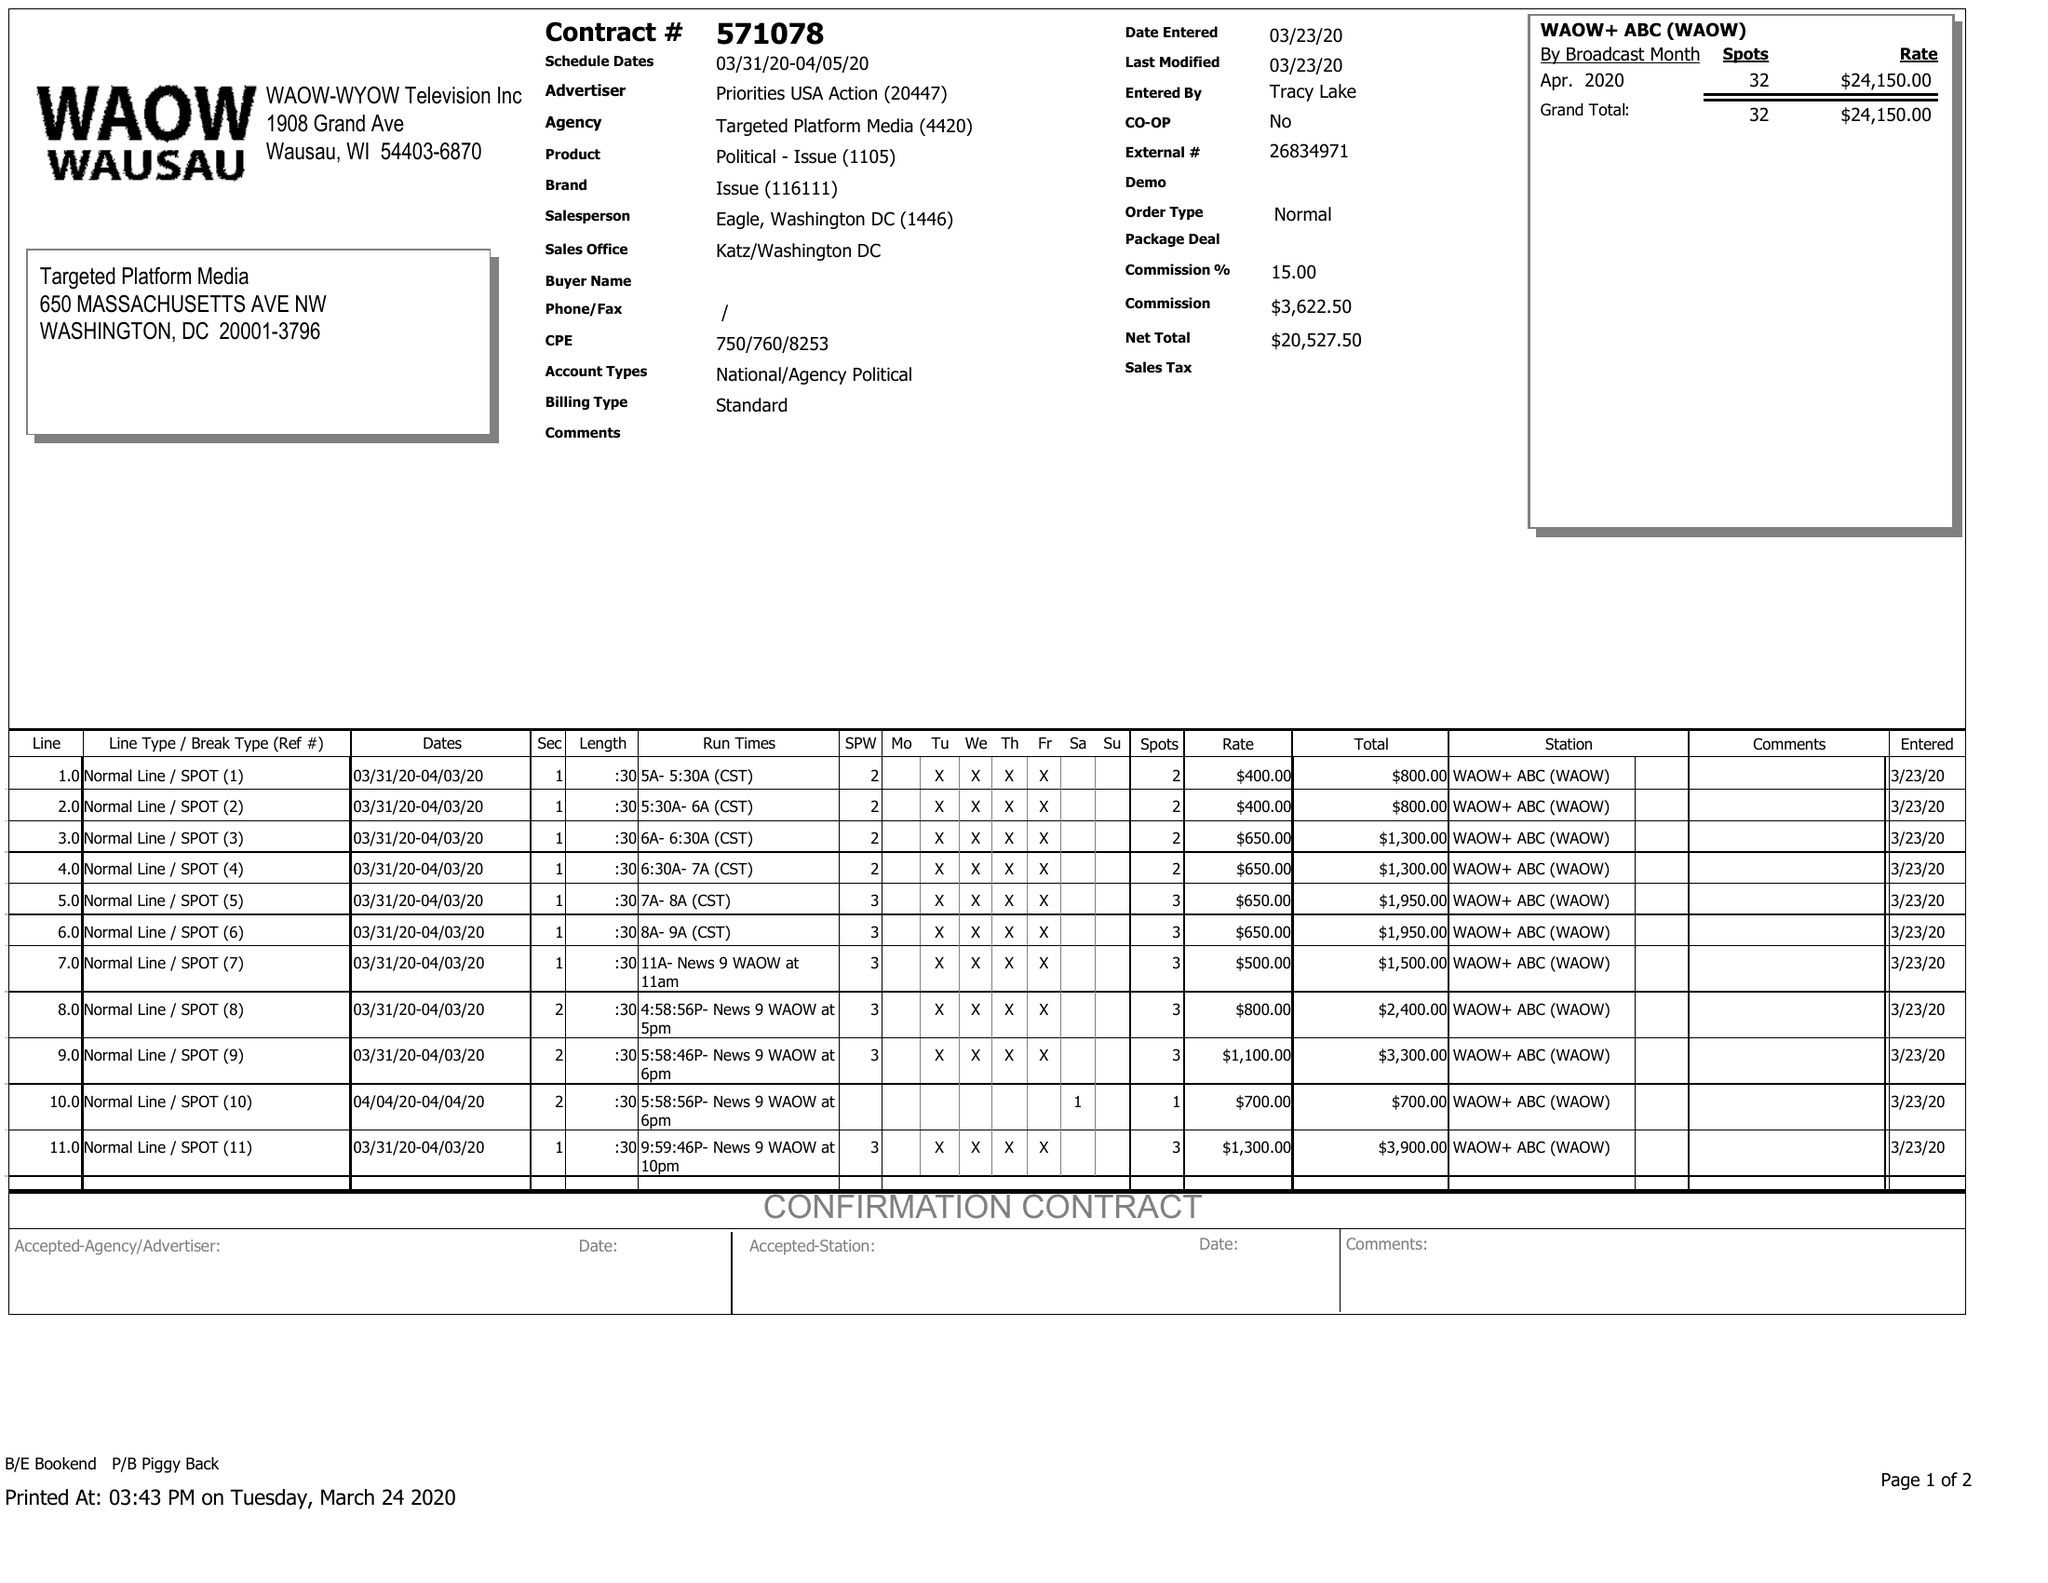What is the value for the contract_num?
Answer the question using a single word or phrase. 571078 